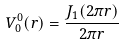Convert formula to latex. <formula><loc_0><loc_0><loc_500><loc_500>V _ { 0 } ^ { 0 } ( r ) = \frac { J _ { 1 } ( 2 \pi r ) } { 2 \pi r }</formula> 